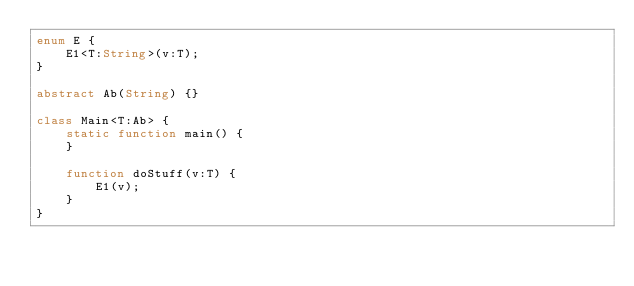<code> <loc_0><loc_0><loc_500><loc_500><_Haxe_>enum E {
    E1<T:String>(v:T);
}

abstract Ab(String) {}

class Main<T:Ab> {
    static function main() {
    }

    function doStuff(v:T) {
        E1(v);
    }
}
</code> 